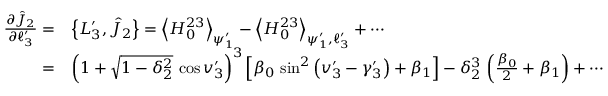Convert formula to latex. <formula><loc_0><loc_0><loc_500><loc_500>\begin{array} { r l } { \frac { \partial \hat { J } _ { 2 } } { \partial \ell _ { 3 } ^ { \prime } } = } & { \left \{ L _ { 3 } ^ { \prime } , \hat { J } _ { 2 } \right \} = \left \langle H _ { 0 } ^ { 2 3 } \right \rangle _ { \psi _ { 1 } ^ { \prime } } - \left \langle H _ { 0 } ^ { 2 3 } \right \rangle _ { \psi _ { 1 } ^ { \prime } , \ell _ { 3 } ^ { \prime } } + \cdots } \\ { = } & { \left ( 1 + \sqrt { 1 - \delta _ { 2 } ^ { 2 } } \, \cos v _ { 3 } ^ { \prime } \right ) ^ { 3 } \left [ \beta _ { 0 } \, \sin ^ { 2 } \left ( v _ { 3 } ^ { \prime } - \gamma _ { 3 } ^ { \prime } \right ) + \beta _ { 1 } \right ] - \delta _ { 2 } ^ { 3 } \, \left ( \frac { \beta _ { 0 } } { 2 } + \beta _ { 1 } \right ) + \cdots } \end{array}</formula> 